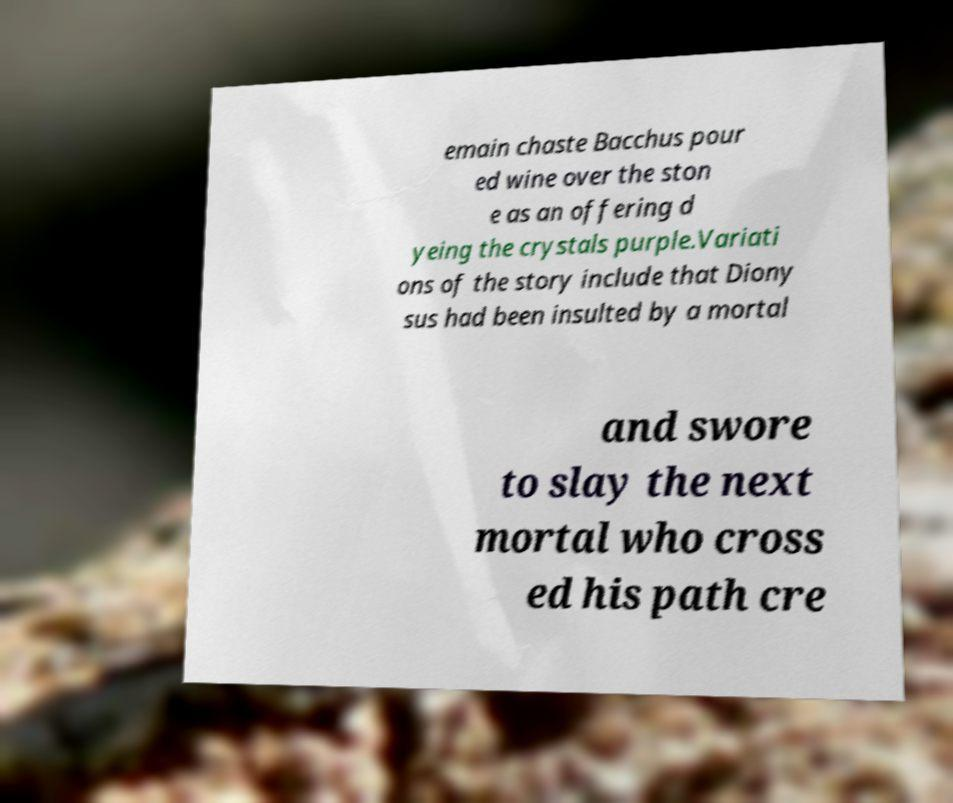Can you read and provide the text displayed in the image?This photo seems to have some interesting text. Can you extract and type it out for me? emain chaste Bacchus pour ed wine over the ston e as an offering d yeing the crystals purple.Variati ons of the story include that Diony sus had been insulted by a mortal and swore to slay the next mortal who cross ed his path cre 